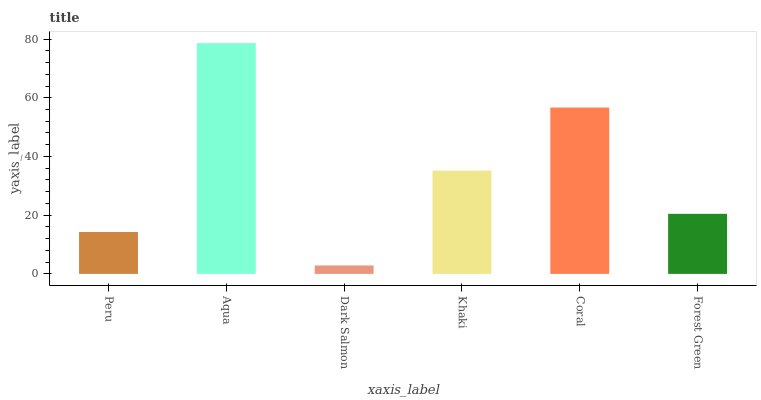Is Dark Salmon the minimum?
Answer yes or no. Yes. Is Aqua the maximum?
Answer yes or no. Yes. Is Aqua the minimum?
Answer yes or no. No. Is Dark Salmon the maximum?
Answer yes or no. No. Is Aqua greater than Dark Salmon?
Answer yes or no. Yes. Is Dark Salmon less than Aqua?
Answer yes or no. Yes. Is Dark Salmon greater than Aqua?
Answer yes or no. No. Is Aqua less than Dark Salmon?
Answer yes or no. No. Is Khaki the high median?
Answer yes or no. Yes. Is Forest Green the low median?
Answer yes or no. Yes. Is Forest Green the high median?
Answer yes or no. No. Is Dark Salmon the low median?
Answer yes or no. No. 